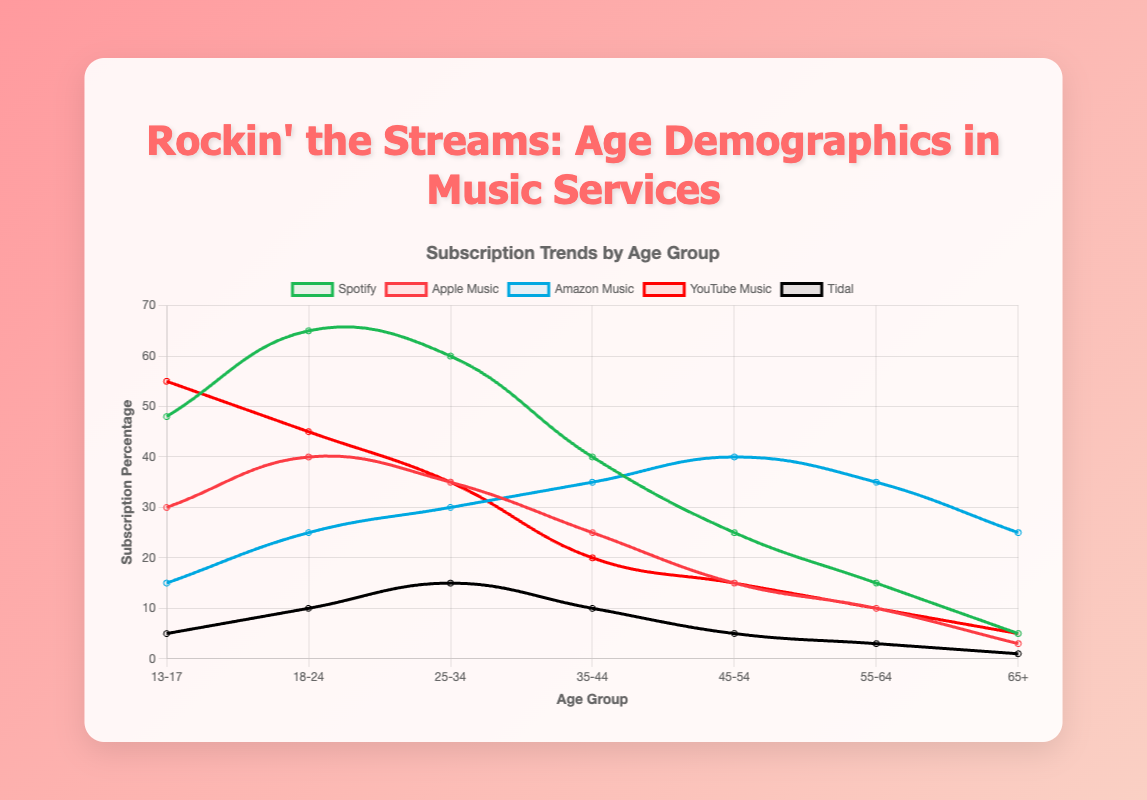What's the most popular music streaming service among the 18-24 age group? Look at the data points for the 18-24 age group. The tallest line represents Spotify with a value of 65.
Answer: Spotify Which age group has the highest subscription rate for Amazon Music? Look at the data points of Amazon Music for all age groups. The highest point on the graph is for the 45-54 age group with a value of 40.
Answer: 45-54 Which age group has the lowest subscription rate for Tidal, and what is the rate? Examine the data points for Tidal across all age groups. The lowest point is for the 65+ age group with a value of 1.
Answer: 65+, 1 Compare the subscription rates for Spotify and YouTube Music in the 25-34 age group. Which is higher? For the 25-34 age group, look at the data points for Spotify and YouTube Music. Spotify has 60 and YouTube Music has 35, so Spotify is higher.
Answer: Spotify For the 13-17 age group, what is the sum of subscription rates for Apple Music and Tidal? The values for the 13-17 age group are 30 for Apple Music and 5 for Tidal. The sum is 30 + 5 = 35.
Answer: 35 Which age group shows the largest difference by subtracting Apple Music subscriptions from Spotify subscriptions? Calculate the differences (Spotify - Apple Music) for each age group: 
13-17: 48 - 30 = 18
18-24: 65 - 40 = 25
25-34: 60 - 35 = 25
35-44: 40 - 25 = 15
45-54: 25 - 15 = 10
55-64: 15 - 10 = 5
65+: 5 - 3 = 2
The largest difference is 25 for both the 18-24 and 25-34 age groups.
Answer: 18-24, 25-34 Which service saw the highest subscriptions among the 13-17 age group, and what visual attribute indicates this? Look for the tallest line among the data points for the 13-17 age group. The highest is YouTube Music with a peak value of 55, indicated by a high point in the graph.
Answer: YouTube Music, height Across all age groups, which service remains consistent in its rise in subscription rates for older demographics? Observe the trend lines for all services across increasing age groups. Amazon Music shows a consistent rise, peaking at the 45-54 group, and slightly lowering for older demographics past that, still maintaining higher than younger ages.
Answer: Amazon Music What's the average subscription rate of Spotify for the age groups 35-44 and 45-54? Add the values for Spotify for the 35-44 (40) and 45-54 (25) age groups. The sum is 40 + 25 = 65. Divide by 2 to find the average: 65 / 2 = 32.5.
Answer: 32.5 